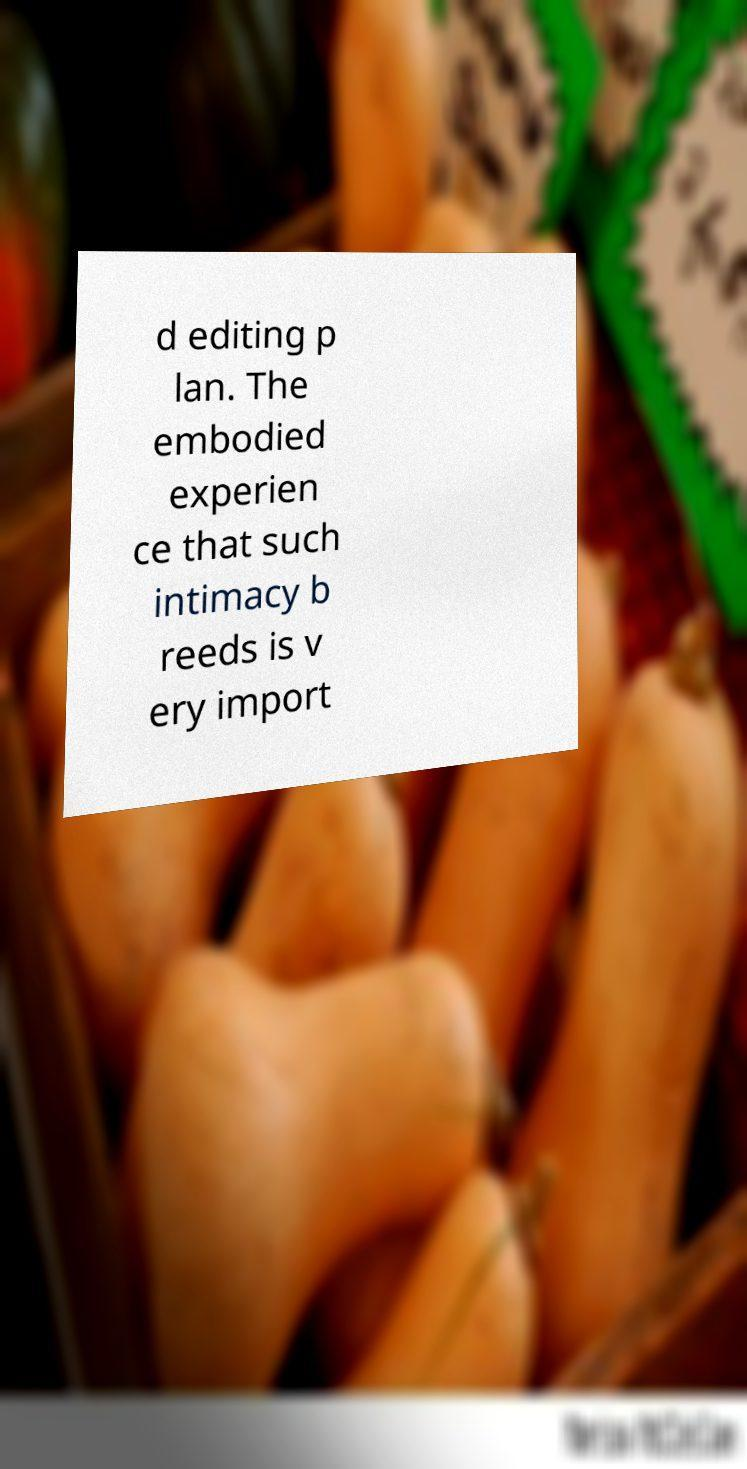Please identify and transcribe the text found in this image. d editing p lan. The embodied experien ce that such intimacy b reeds is v ery import 